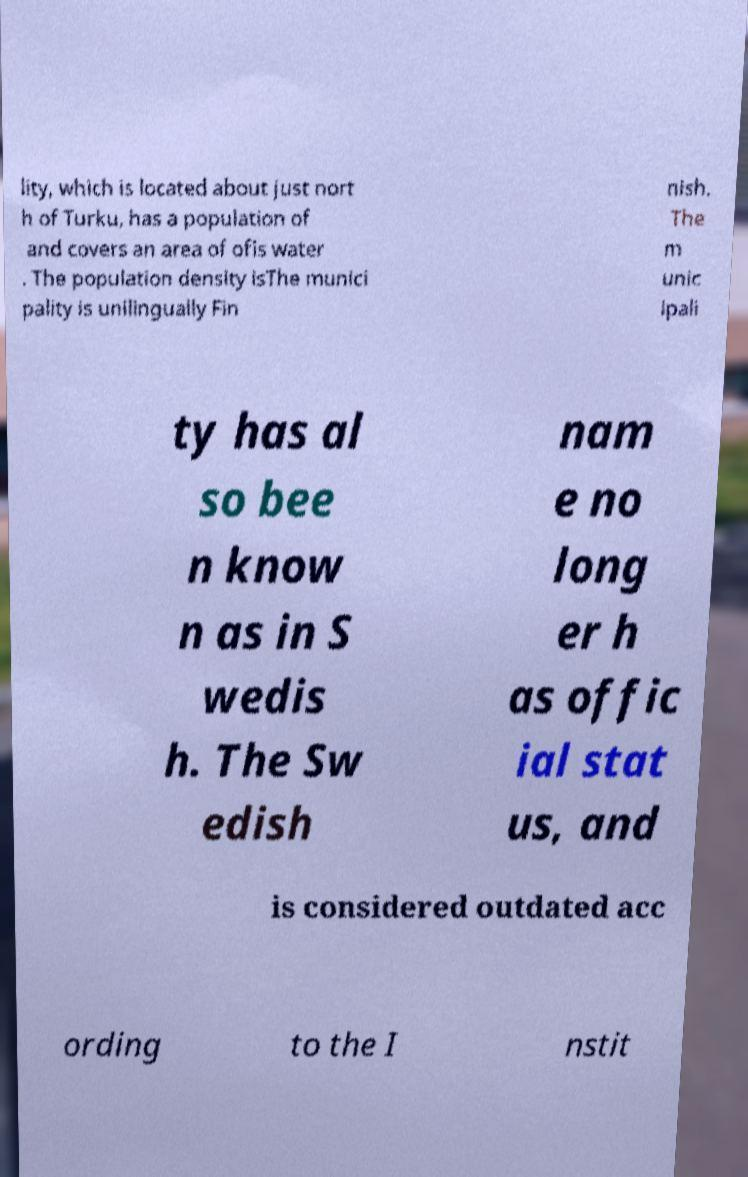Please identify and transcribe the text found in this image. lity, which is located about just nort h of Turku, has a population of and covers an area of ofis water . The population density isThe munici pality is unilingually Fin nish. The m unic ipali ty has al so bee n know n as in S wedis h. The Sw edish nam e no long er h as offic ial stat us, and is considered outdated acc ording to the I nstit 